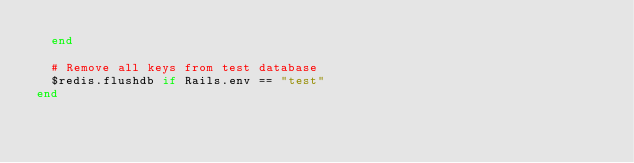Convert code to text. <code><loc_0><loc_0><loc_500><loc_500><_Ruby_>  end

  # Remove all keys from test database
  $redis.flushdb if Rails.env == "test"
end</code> 